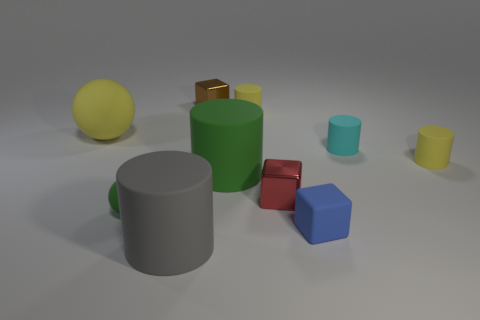There is a blue thing that is the same shape as the brown object; what material is it?
Your answer should be very brief. Rubber. What is the color of the small rubber sphere?
Offer a terse response. Green. What number of matte objects are tiny cyan cylinders or tiny balls?
Keep it short and to the point. 2. There is a metal object that is left of the large cylinder that is behind the tiny blue cube; are there any tiny blue matte cubes that are on the right side of it?
Offer a terse response. Yes. What is the size of the gray cylinder that is made of the same material as the small green thing?
Your answer should be compact. Large. There is a tiny blue object; are there any tiny red blocks to the right of it?
Your answer should be compact. No. There is a metallic cube that is on the left side of the green matte cylinder; are there any cubes that are in front of it?
Ensure brevity in your answer.  Yes. Is the size of the matte cylinder left of the brown block the same as the yellow rubber cylinder on the left side of the small blue object?
Your answer should be compact. No. How many big objects are brown metallic things or blue metal things?
Offer a terse response. 0. There is a red block behind the big cylinder that is in front of the rubber block; what is it made of?
Keep it short and to the point. Metal. 